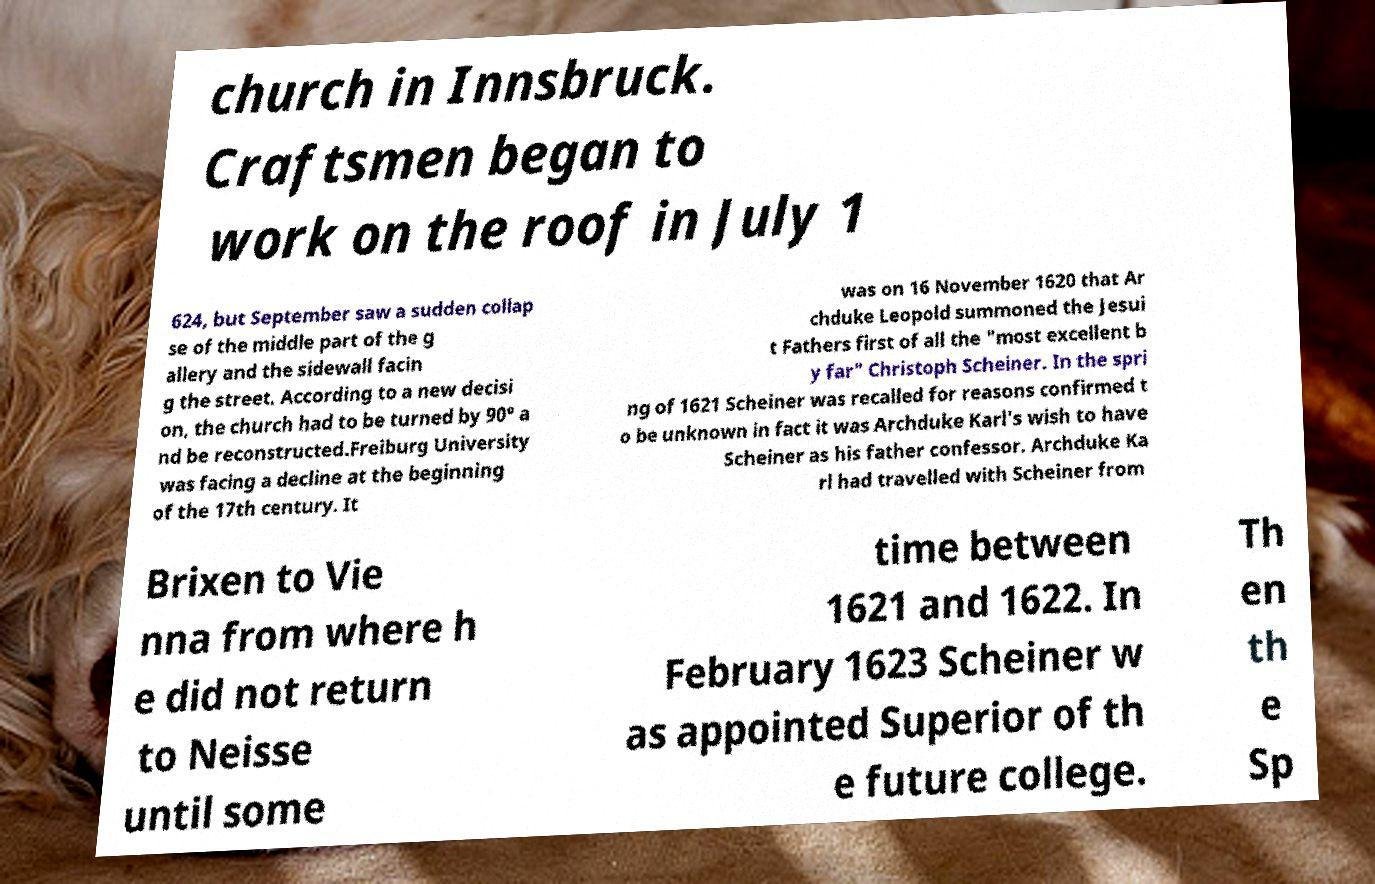What messages or text are displayed in this image? I need them in a readable, typed format. church in Innsbruck. Craftsmen began to work on the roof in July 1 624, but September saw a sudden collap se of the middle part of the g allery and the sidewall facin g the street. According to a new decisi on, the church had to be turned by 90° a nd be reconstructed.Freiburg University was facing a decline at the beginning of the 17th century. It was on 16 November 1620 that Ar chduke Leopold summoned the Jesui t Fathers first of all the "most excellent b y far" Christoph Scheiner. In the spri ng of 1621 Scheiner was recalled for reasons confirmed t o be unknown in fact it was Archduke Karl's wish to have Scheiner as his father confessor. Archduke Ka rl had travelled with Scheiner from Brixen to Vie nna from where h e did not return to Neisse until some time between 1621 and 1622. In February 1623 Scheiner w as appointed Superior of th e future college. Th en th e Sp 